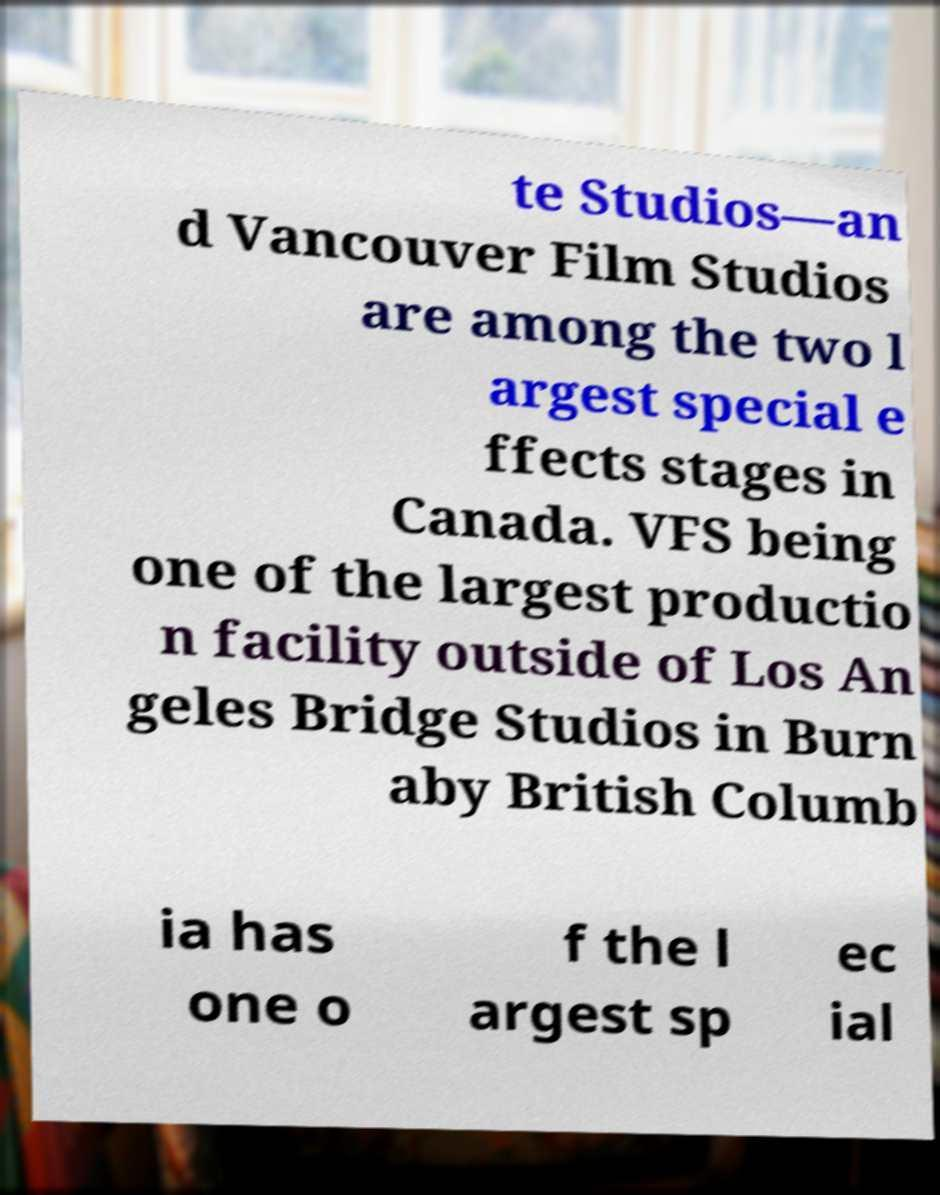Could you extract and type out the text from this image? te Studios—an d Vancouver Film Studios are among the two l argest special e ffects stages in Canada. VFS being one of the largest productio n facility outside of Los An geles Bridge Studios in Burn aby British Columb ia has one o f the l argest sp ec ial 